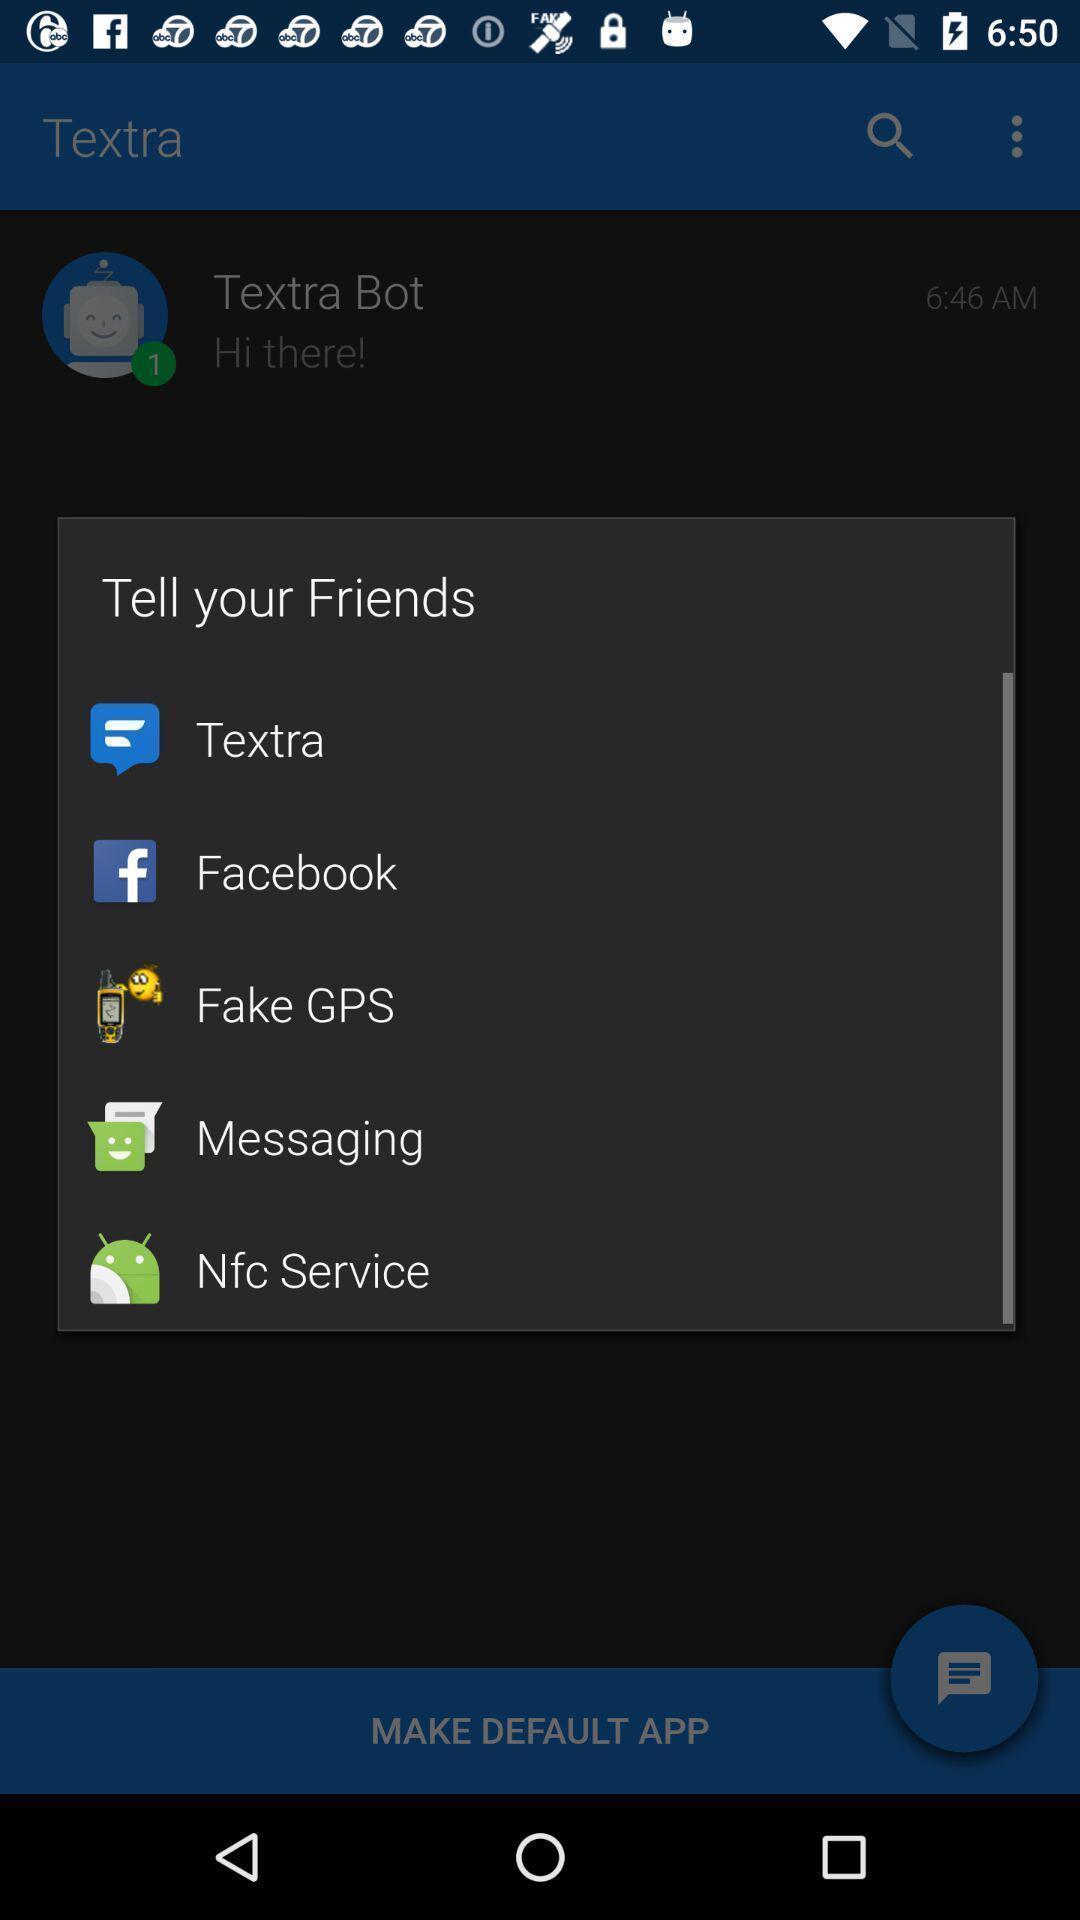Give me a summary of this screen capture. Pop up to share through various applications. 